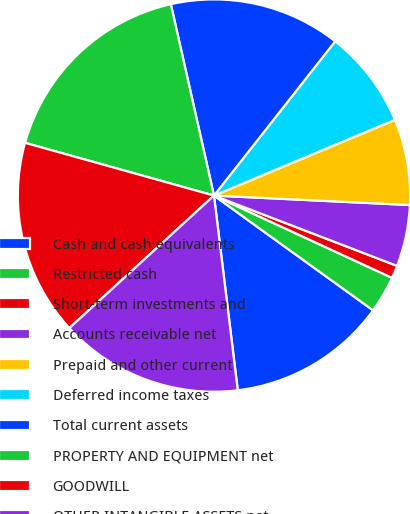<chart> <loc_0><loc_0><loc_500><loc_500><pie_chart><fcel>Cash and cash equivalents<fcel>Restricted cash<fcel>Short-term investments and<fcel>Accounts receivable net<fcel>Prepaid and other current<fcel>Deferred income taxes<fcel>Total current assets<fcel>PROPERTY AND EQUIPMENT net<fcel>GOODWILL<fcel>OTHER INTANGIBLE ASSETS net<nl><fcel>13.12%<fcel>3.06%<fcel>1.05%<fcel>5.07%<fcel>7.08%<fcel>8.09%<fcel>14.13%<fcel>17.14%<fcel>16.14%<fcel>15.13%<nl></chart> 